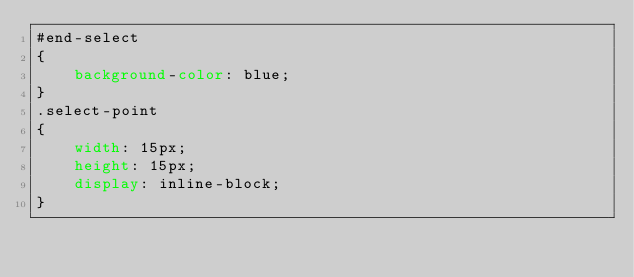Convert code to text. <code><loc_0><loc_0><loc_500><loc_500><_CSS_>#end-select
{
    background-color: blue;
}
.select-point
{
    width: 15px;
    height: 15px;
    display: inline-block;
}
</code> 